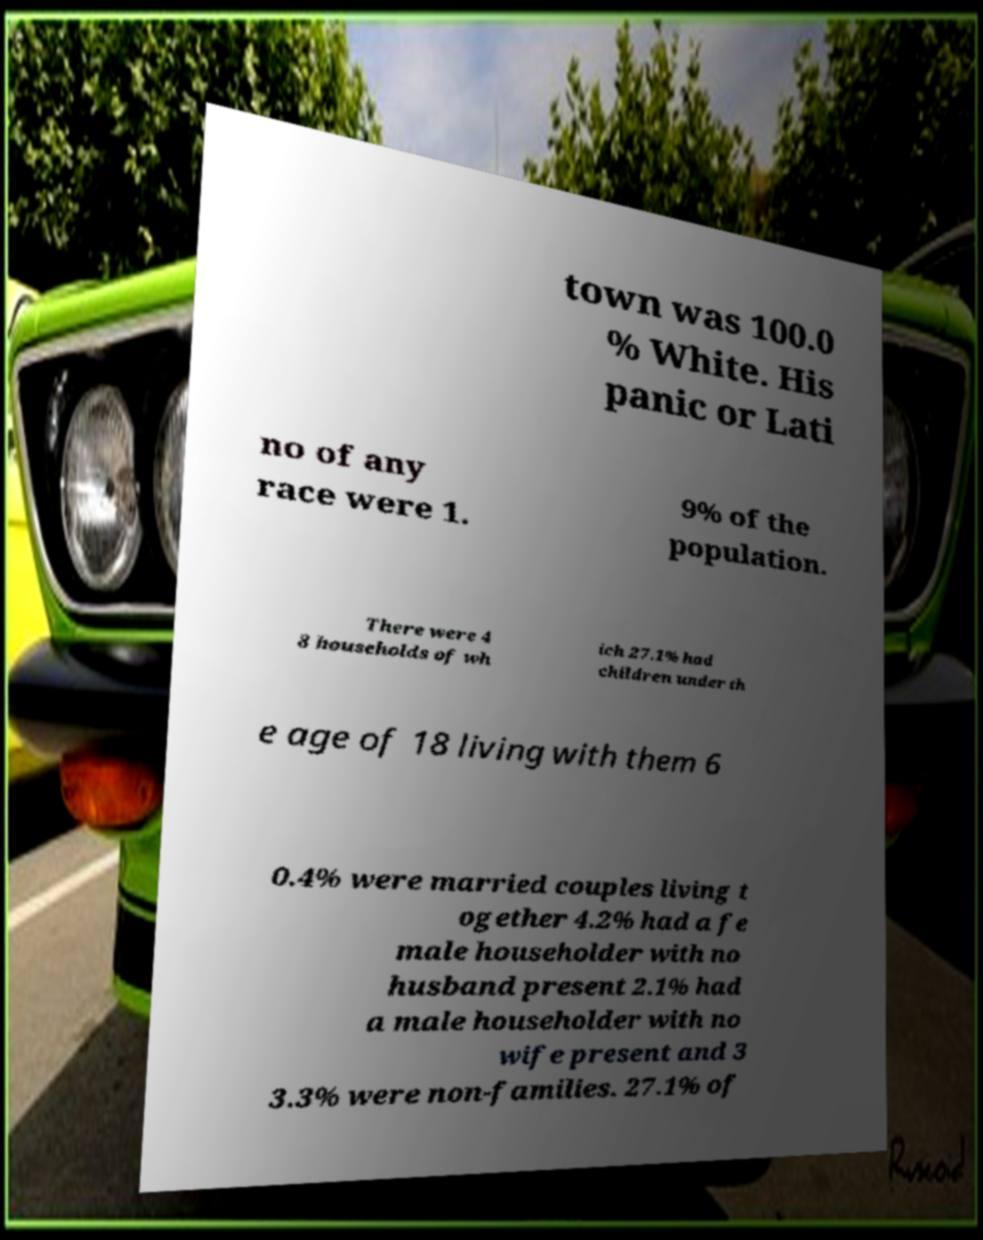What messages or text are displayed in this image? I need them in a readable, typed format. town was 100.0 % White. His panic or Lati no of any race were 1. 9% of the population. There were 4 8 households of wh ich 27.1% had children under th e age of 18 living with them 6 0.4% were married couples living t ogether 4.2% had a fe male householder with no husband present 2.1% had a male householder with no wife present and 3 3.3% were non-families. 27.1% of 